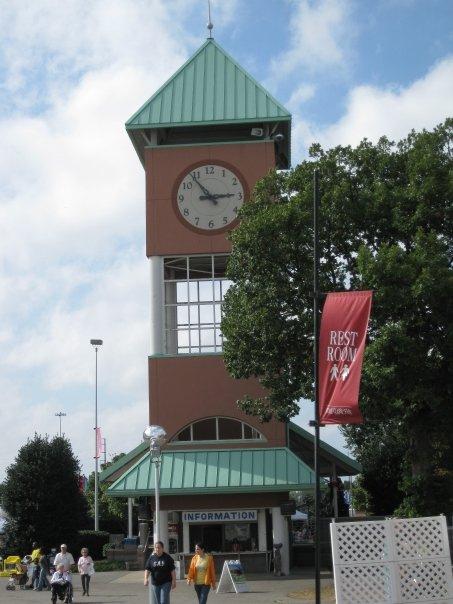Is the time pm?
Give a very brief answer. Yes. What's in front of the clock tower?
Write a very short answer. People. Is the person in a hurry?
Answer briefly. No. How many stars on are on the flags?
Short answer required. 0. Is the neighborhood old or new?
Short answer required. New. Are these people on vacation?
Answer briefly. Yes. Who is the clockmaker?
Answer briefly. Unknown. What is another term for restroom?
Write a very short answer. Bathroom. Where is the clock?
Short answer required. Tower. What time is it in the photo?
Be succinct. 2:54. Is the clock in Roman numerals?
Give a very brief answer. No. 